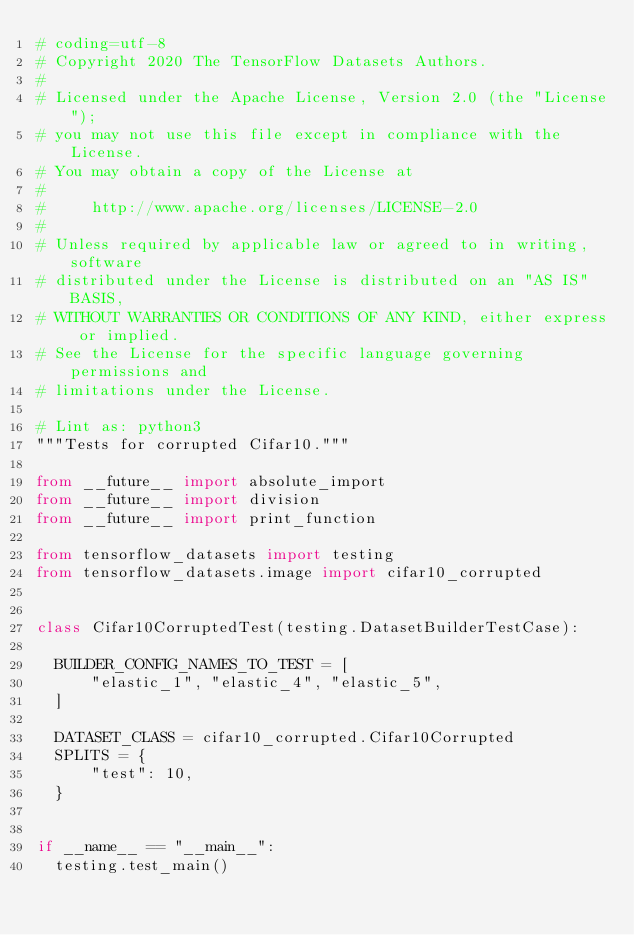Convert code to text. <code><loc_0><loc_0><loc_500><loc_500><_Python_># coding=utf-8
# Copyright 2020 The TensorFlow Datasets Authors.
#
# Licensed under the Apache License, Version 2.0 (the "License");
# you may not use this file except in compliance with the License.
# You may obtain a copy of the License at
#
#     http://www.apache.org/licenses/LICENSE-2.0
#
# Unless required by applicable law or agreed to in writing, software
# distributed under the License is distributed on an "AS IS" BASIS,
# WITHOUT WARRANTIES OR CONDITIONS OF ANY KIND, either express or implied.
# See the License for the specific language governing permissions and
# limitations under the License.

# Lint as: python3
"""Tests for corrupted Cifar10."""

from __future__ import absolute_import
from __future__ import division
from __future__ import print_function

from tensorflow_datasets import testing
from tensorflow_datasets.image import cifar10_corrupted


class Cifar10CorruptedTest(testing.DatasetBuilderTestCase):

  BUILDER_CONFIG_NAMES_TO_TEST = [
      "elastic_1", "elastic_4", "elastic_5",
  ]

  DATASET_CLASS = cifar10_corrupted.Cifar10Corrupted
  SPLITS = {
      "test": 10,
  }


if __name__ == "__main__":
  testing.test_main()
</code> 